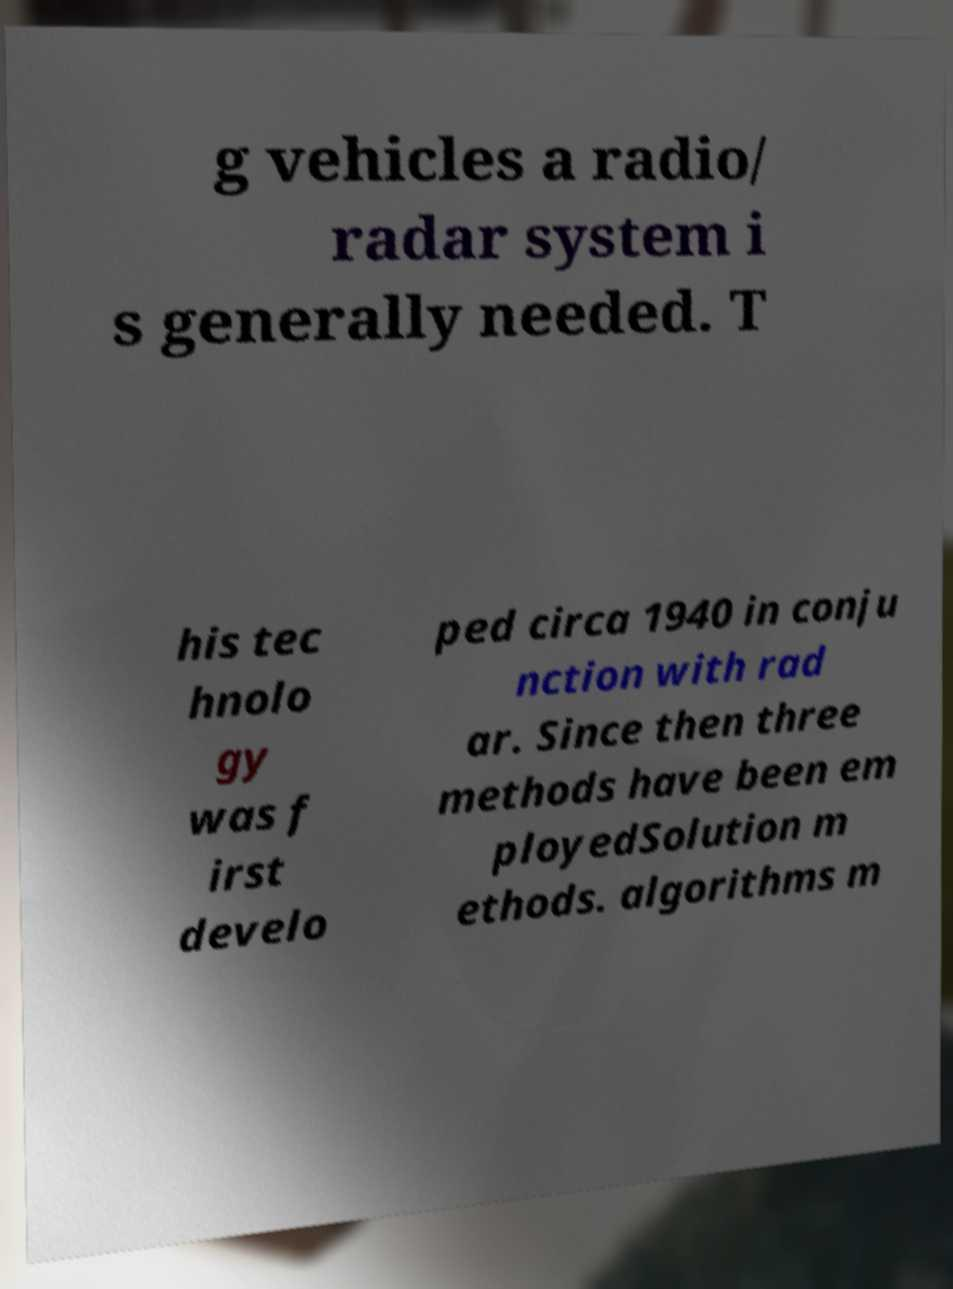Can you read and provide the text displayed in the image?This photo seems to have some interesting text. Can you extract and type it out for me? g vehicles a radio/ radar system i s generally needed. T his tec hnolo gy was f irst develo ped circa 1940 in conju nction with rad ar. Since then three methods have been em ployedSolution m ethods. algorithms m 